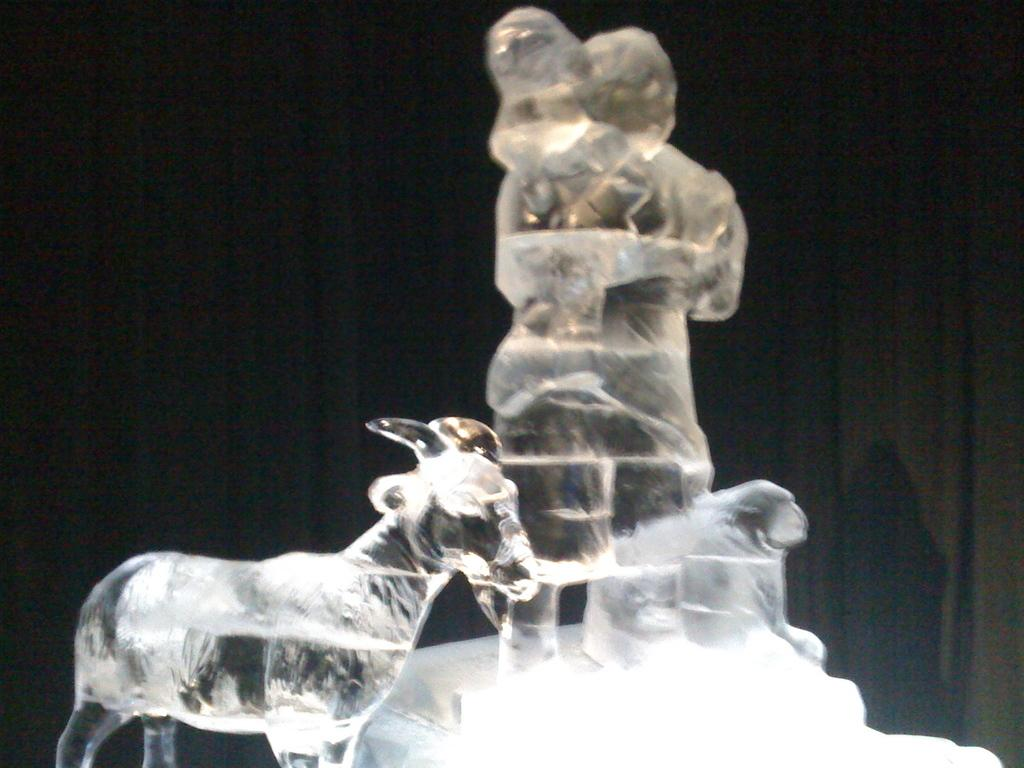What type of objects are present in the image? There are ice objects in the image. Can you describe the background of the image? There is a black color curtain in the background of the image. What type of insect can be seen crawling on the chin of the person in the image? There is no person or chin present in the image, and therefore no insect can be seen crawling on it. 